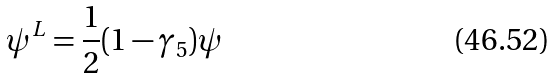Convert formula to latex. <formula><loc_0><loc_0><loc_500><loc_500>\psi ^ { L } = \frac { 1 } { 2 } ( 1 - \gamma _ { 5 } ) \psi</formula> 